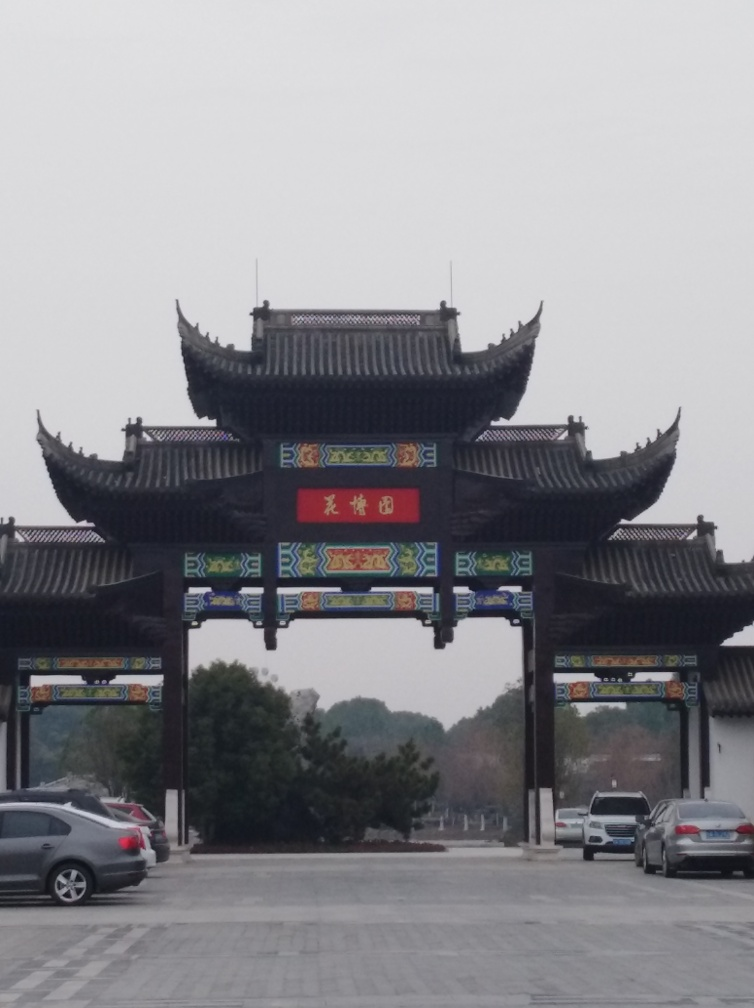What might be the significance of this location? Given the grandiose style of the gate and its decorative elements, this location could be an entrance to a temple, historic district, or a place of significant cultural heritage in China. Such gates are designed to convey a sense of respect and reverence, serving both as a boundary and as a welcoming landmark. If I were to visit, what would you recommend seeing or doing in the area? Visitors to areas like the one depicted in the image should explore the cultural and historical landmarks, participate in any available tours to learn more about the site's history, enjoy local cuisine, and possibly partake in traditional activities or festivals if available. 